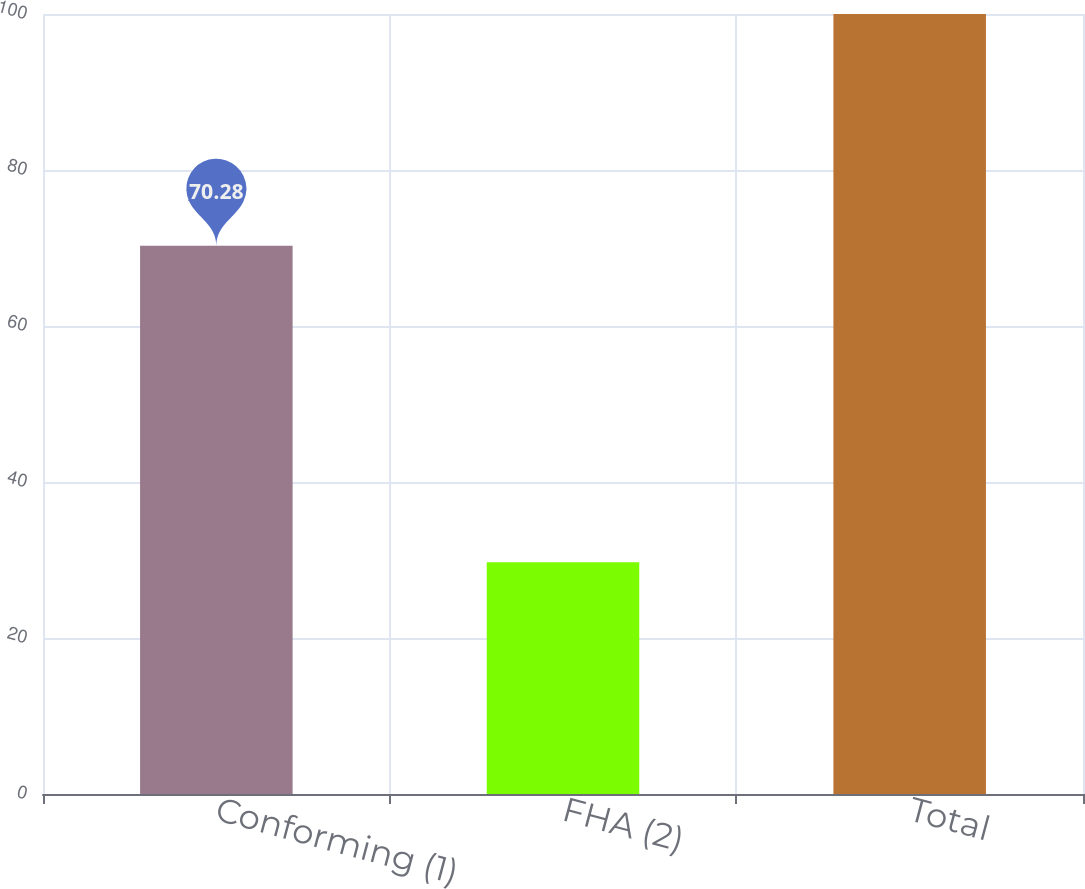Convert chart. <chart><loc_0><loc_0><loc_500><loc_500><bar_chart><fcel>Conforming (1)<fcel>FHA (2)<fcel>Total<nl><fcel>70.28<fcel>29.72<fcel>100<nl></chart> 